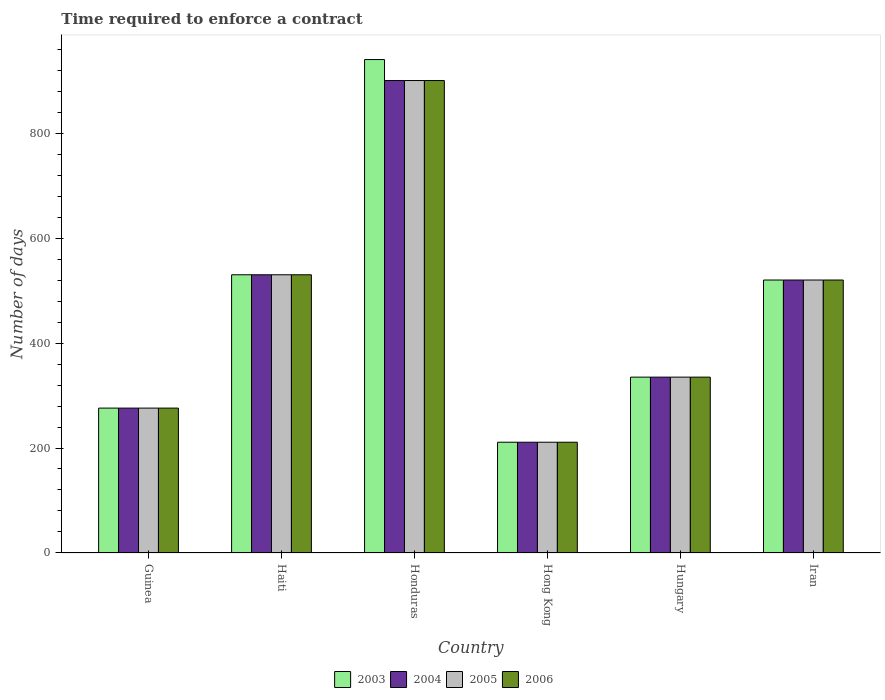How many bars are there on the 4th tick from the left?
Make the answer very short. 4. What is the label of the 1st group of bars from the left?
Keep it short and to the point. Guinea. What is the number of days required to enforce a contract in 2003 in Honduras?
Your response must be concise. 940. Across all countries, what is the maximum number of days required to enforce a contract in 2006?
Offer a terse response. 900. Across all countries, what is the minimum number of days required to enforce a contract in 2006?
Make the answer very short. 211. In which country was the number of days required to enforce a contract in 2003 maximum?
Offer a very short reply. Honduras. In which country was the number of days required to enforce a contract in 2004 minimum?
Your answer should be compact. Hong Kong. What is the total number of days required to enforce a contract in 2003 in the graph?
Ensure brevity in your answer.  2812. What is the difference between the number of days required to enforce a contract in 2004 in Guinea and that in Haiti?
Keep it short and to the point. -254. What is the difference between the number of days required to enforce a contract in 2003 in Hungary and the number of days required to enforce a contract in 2005 in Iran?
Your answer should be very brief. -185. What is the average number of days required to enforce a contract in 2006 per country?
Your answer should be very brief. 462. What is the difference between the number of days required to enforce a contract of/in 2006 and number of days required to enforce a contract of/in 2003 in Guinea?
Your response must be concise. 0. In how many countries, is the number of days required to enforce a contract in 2005 greater than 200 days?
Make the answer very short. 6. What is the ratio of the number of days required to enforce a contract in 2003 in Guinea to that in Iran?
Offer a very short reply. 0.53. Is the number of days required to enforce a contract in 2003 in Haiti less than that in Iran?
Keep it short and to the point. No. What is the difference between the highest and the second highest number of days required to enforce a contract in 2004?
Provide a short and direct response. -10. What is the difference between the highest and the lowest number of days required to enforce a contract in 2006?
Your response must be concise. 689. In how many countries, is the number of days required to enforce a contract in 2004 greater than the average number of days required to enforce a contract in 2004 taken over all countries?
Offer a very short reply. 3. Is the sum of the number of days required to enforce a contract in 2006 in Guinea and Iran greater than the maximum number of days required to enforce a contract in 2005 across all countries?
Provide a short and direct response. No. What does the 2nd bar from the left in Hong Kong represents?
Your answer should be compact. 2004. What does the 1st bar from the right in Hong Kong represents?
Your response must be concise. 2006. Is it the case that in every country, the sum of the number of days required to enforce a contract in 2004 and number of days required to enforce a contract in 2006 is greater than the number of days required to enforce a contract in 2003?
Your answer should be compact. Yes. How many bars are there?
Your answer should be very brief. 24. Are all the bars in the graph horizontal?
Your response must be concise. No. How many countries are there in the graph?
Provide a succinct answer. 6. Are the values on the major ticks of Y-axis written in scientific E-notation?
Make the answer very short. No. Does the graph contain any zero values?
Offer a terse response. No. Does the graph contain grids?
Offer a terse response. No. How many legend labels are there?
Provide a short and direct response. 4. How are the legend labels stacked?
Ensure brevity in your answer.  Horizontal. What is the title of the graph?
Keep it short and to the point. Time required to enforce a contract. Does "1986" appear as one of the legend labels in the graph?
Your answer should be compact. No. What is the label or title of the Y-axis?
Provide a short and direct response. Number of days. What is the Number of days in 2003 in Guinea?
Your answer should be very brief. 276. What is the Number of days of 2004 in Guinea?
Your response must be concise. 276. What is the Number of days in 2005 in Guinea?
Keep it short and to the point. 276. What is the Number of days of 2006 in Guinea?
Your response must be concise. 276. What is the Number of days of 2003 in Haiti?
Make the answer very short. 530. What is the Number of days of 2004 in Haiti?
Your response must be concise. 530. What is the Number of days in 2005 in Haiti?
Provide a short and direct response. 530. What is the Number of days in 2006 in Haiti?
Your response must be concise. 530. What is the Number of days of 2003 in Honduras?
Your answer should be very brief. 940. What is the Number of days in 2004 in Honduras?
Make the answer very short. 900. What is the Number of days in 2005 in Honduras?
Provide a succinct answer. 900. What is the Number of days of 2006 in Honduras?
Give a very brief answer. 900. What is the Number of days in 2003 in Hong Kong?
Your answer should be very brief. 211. What is the Number of days of 2004 in Hong Kong?
Offer a terse response. 211. What is the Number of days in 2005 in Hong Kong?
Make the answer very short. 211. What is the Number of days of 2006 in Hong Kong?
Make the answer very short. 211. What is the Number of days in 2003 in Hungary?
Provide a succinct answer. 335. What is the Number of days of 2004 in Hungary?
Offer a very short reply. 335. What is the Number of days of 2005 in Hungary?
Give a very brief answer. 335. What is the Number of days in 2006 in Hungary?
Give a very brief answer. 335. What is the Number of days in 2003 in Iran?
Your response must be concise. 520. What is the Number of days of 2004 in Iran?
Make the answer very short. 520. What is the Number of days of 2005 in Iran?
Provide a succinct answer. 520. What is the Number of days in 2006 in Iran?
Your response must be concise. 520. Across all countries, what is the maximum Number of days in 2003?
Ensure brevity in your answer.  940. Across all countries, what is the maximum Number of days of 2004?
Provide a short and direct response. 900. Across all countries, what is the maximum Number of days of 2005?
Give a very brief answer. 900. Across all countries, what is the maximum Number of days of 2006?
Offer a very short reply. 900. Across all countries, what is the minimum Number of days of 2003?
Offer a terse response. 211. Across all countries, what is the minimum Number of days in 2004?
Your answer should be very brief. 211. Across all countries, what is the minimum Number of days in 2005?
Make the answer very short. 211. Across all countries, what is the minimum Number of days in 2006?
Keep it short and to the point. 211. What is the total Number of days of 2003 in the graph?
Your answer should be very brief. 2812. What is the total Number of days in 2004 in the graph?
Your response must be concise. 2772. What is the total Number of days in 2005 in the graph?
Offer a very short reply. 2772. What is the total Number of days in 2006 in the graph?
Provide a succinct answer. 2772. What is the difference between the Number of days of 2003 in Guinea and that in Haiti?
Ensure brevity in your answer.  -254. What is the difference between the Number of days of 2004 in Guinea and that in Haiti?
Provide a short and direct response. -254. What is the difference between the Number of days in 2005 in Guinea and that in Haiti?
Your answer should be compact. -254. What is the difference between the Number of days in 2006 in Guinea and that in Haiti?
Your answer should be very brief. -254. What is the difference between the Number of days of 2003 in Guinea and that in Honduras?
Provide a short and direct response. -664. What is the difference between the Number of days of 2004 in Guinea and that in Honduras?
Provide a succinct answer. -624. What is the difference between the Number of days of 2005 in Guinea and that in Honduras?
Your answer should be very brief. -624. What is the difference between the Number of days of 2006 in Guinea and that in Honduras?
Keep it short and to the point. -624. What is the difference between the Number of days in 2005 in Guinea and that in Hong Kong?
Provide a short and direct response. 65. What is the difference between the Number of days of 2006 in Guinea and that in Hong Kong?
Make the answer very short. 65. What is the difference between the Number of days in 2003 in Guinea and that in Hungary?
Give a very brief answer. -59. What is the difference between the Number of days in 2004 in Guinea and that in Hungary?
Keep it short and to the point. -59. What is the difference between the Number of days of 2005 in Guinea and that in Hungary?
Offer a terse response. -59. What is the difference between the Number of days of 2006 in Guinea and that in Hungary?
Offer a very short reply. -59. What is the difference between the Number of days of 2003 in Guinea and that in Iran?
Your answer should be compact. -244. What is the difference between the Number of days of 2004 in Guinea and that in Iran?
Give a very brief answer. -244. What is the difference between the Number of days of 2005 in Guinea and that in Iran?
Ensure brevity in your answer.  -244. What is the difference between the Number of days in 2006 in Guinea and that in Iran?
Offer a terse response. -244. What is the difference between the Number of days of 2003 in Haiti and that in Honduras?
Provide a short and direct response. -410. What is the difference between the Number of days in 2004 in Haiti and that in Honduras?
Give a very brief answer. -370. What is the difference between the Number of days of 2005 in Haiti and that in Honduras?
Give a very brief answer. -370. What is the difference between the Number of days in 2006 in Haiti and that in Honduras?
Your answer should be compact. -370. What is the difference between the Number of days in 2003 in Haiti and that in Hong Kong?
Offer a terse response. 319. What is the difference between the Number of days in 2004 in Haiti and that in Hong Kong?
Keep it short and to the point. 319. What is the difference between the Number of days in 2005 in Haiti and that in Hong Kong?
Give a very brief answer. 319. What is the difference between the Number of days of 2006 in Haiti and that in Hong Kong?
Your response must be concise. 319. What is the difference between the Number of days of 2003 in Haiti and that in Hungary?
Your answer should be very brief. 195. What is the difference between the Number of days of 2004 in Haiti and that in Hungary?
Offer a terse response. 195. What is the difference between the Number of days of 2005 in Haiti and that in Hungary?
Keep it short and to the point. 195. What is the difference between the Number of days of 2006 in Haiti and that in Hungary?
Offer a terse response. 195. What is the difference between the Number of days in 2003 in Haiti and that in Iran?
Offer a terse response. 10. What is the difference between the Number of days of 2003 in Honduras and that in Hong Kong?
Provide a short and direct response. 729. What is the difference between the Number of days of 2004 in Honduras and that in Hong Kong?
Keep it short and to the point. 689. What is the difference between the Number of days in 2005 in Honduras and that in Hong Kong?
Your response must be concise. 689. What is the difference between the Number of days in 2006 in Honduras and that in Hong Kong?
Ensure brevity in your answer.  689. What is the difference between the Number of days of 2003 in Honduras and that in Hungary?
Keep it short and to the point. 605. What is the difference between the Number of days in 2004 in Honduras and that in Hungary?
Ensure brevity in your answer.  565. What is the difference between the Number of days in 2005 in Honduras and that in Hungary?
Your answer should be compact. 565. What is the difference between the Number of days of 2006 in Honduras and that in Hungary?
Your answer should be compact. 565. What is the difference between the Number of days of 2003 in Honduras and that in Iran?
Your answer should be compact. 420. What is the difference between the Number of days in 2004 in Honduras and that in Iran?
Provide a succinct answer. 380. What is the difference between the Number of days in 2005 in Honduras and that in Iran?
Offer a terse response. 380. What is the difference between the Number of days of 2006 in Honduras and that in Iran?
Make the answer very short. 380. What is the difference between the Number of days of 2003 in Hong Kong and that in Hungary?
Your answer should be compact. -124. What is the difference between the Number of days of 2004 in Hong Kong and that in Hungary?
Make the answer very short. -124. What is the difference between the Number of days in 2005 in Hong Kong and that in Hungary?
Offer a terse response. -124. What is the difference between the Number of days in 2006 in Hong Kong and that in Hungary?
Make the answer very short. -124. What is the difference between the Number of days in 2003 in Hong Kong and that in Iran?
Your answer should be very brief. -309. What is the difference between the Number of days of 2004 in Hong Kong and that in Iran?
Make the answer very short. -309. What is the difference between the Number of days of 2005 in Hong Kong and that in Iran?
Provide a short and direct response. -309. What is the difference between the Number of days in 2006 in Hong Kong and that in Iran?
Provide a succinct answer. -309. What is the difference between the Number of days in 2003 in Hungary and that in Iran?
Your answer should be compact. -185. What is the difference between the Number of days of 2004 in Hungary and that in Iran?
Provide a succinct answer. -185. What is the difference between the Number of days of 2005 in Hungary and that in Iran?
Offer a terse response. -185. What is the difference between the Number of days in 2006 in Hungary and that in Iran?
Your response must be concise. -185. What is the difference between the Number of days in 2003 in Guinea and the Number of days in 2004 in Haiti?
Offer a very short reply. -254. What is the difference between the Number of days of 2003 in Guinea and the Number of days of 2005 in Haiti?
Make the answer very short. -254. What is the difference between the Number of days in 2003 in Guinea and the Number of days in 2006 in Haiti?
Keep it short and to the point. -254. What is the difference between the Number of days in 2004 in Guinea and the Number of days in 2005 in Haiti?
Your answer should be very brief. -254. What is the difference between the Number of days of 2004 in Guinea and the Number of days of 2006 in Haiti?
Provide a short and direct response. -254. What is the difference between the Number of days of 2005 in Guinea and the Number of days of 2006 in Haiti?
Keep it short and to the point. -254. What is the difference between the Number of days of 2003 in Guinea and the Number of days of 2004 in Honduras?
Offer a terse response. -624. What is the difference between the Number of days of 2003 in Guinea and the Number of days of 2005 in Honduras?
Give a very brief answer. -624. What is the difference between the Number of days in 2003 in Guinea and the Number of days in 2006 in Honduras?
Keep it short and to the point. -624. What is the difference between the Number of days of 2004 in Guinea and the Number of days of 2005 in Honduras?
Keep it short and to the point. -624. What is the difference between the Number of days in 2004 in Guinea and the Number of days in 2006 in Honduras?
Your answer should be compact. -624. What is the difference between the Number of days of 2005 in Guinea and the Number of days of 2006 in Honduras?
Your answer should be very brief. -624. What is the difference between the Number of days in 2003 in Guinea and the Number of days in 2005 in Hong Kong?
Offer a terse response. 65. What is the difference between the Number of days in 2003 in Guinea and the Number of days in 2006 in Hong Kong?
Your answer should be very brief. 65. What is the difference between the Number of days of 2004 in Guinea and the Number of days of 2005 in Hong Kong?
Your answer should be compact. 65. What is the difference between the Number of days in 2003 in Guinea and the Number of days in 2004 in Hungary?
Make the answer very short. -59. What is the difference between the Number of days in 2003 in Guinea and the Number of days in 2005 in Hungary?
Offer a very short reply. -59. What is the difference between the Number of days in 2003 in Guinea and the Number of days in 2006 in Hungary?
Your response must be concise. -59. What is the difference between the Number of days of 2004 in Guinea and the Number of days of 2005 in Hungary?
Your response must be concise. -59. What is the difference between the Number of days of 2004 in Guinea and the Number of days of 2006 in Hungary?
Your answer should be compact. -59. What is the difference between the Number of days in 2005 in Guinea and the Number of days in 2006 in Hungary?
Your answer should be compact. -59. What is the difference between the Number of days in 2003 in Guinea and the Number of days in 2004 in Iran?
Make the answer very short. -244. What is the difference between the Number of days of 2003 in Guinea and the Number of days of 2005 in Iran?
Make the answer very short. -244. What is the difference between the Number of days in 2003 in Guinea and the Number of days in 2006 in Iran?
Ensure brevity in your answer.  -244. What is the difference between the Number of days of 2004 in Guinea and the Number of days of 2005 in Iran?
Keep it short and to the point. -244. What is the difference between the Number of days of 2004 in Guinea and the Number of days of 2006 in Iran?
Ensure brevity in your answer.  -244. What is the difference between the Number of days of 2005 in Guinea and the Number of days of 2006 in Iran?
Your answer should be compact. -244. What is the difference between the Number of days in 2003 in Haiti and the Number of days in 2004 in Honduras?
Offer a very short reply. -370. What is the difference between the Number of days in 2003 in Haiti and the Number of days in 2005 in Honduras?
Provide a succinct answer. -370. What is the difference between the Number of days in 2003 in Haiti and the Number of days in 2006 in Honduras?
Offer a very short reply. -370. What is the difference between the Number of days of 2004 in Haiti and the Number of days of 2005 in Honduras?
Provide a short and direct response. -370. What is the difference between the Number of days of 2004 in Haiti and the Number of days of 2006 in Honduras?
Make the answer very short. -370. What is the difference between the Number of days in 2005 in Haiti and the Number of days in 2006 in Honduras?
Make the answer very short. -370. What is the difference between the Number of days in 2003 in Haiti and the Number of days in 2004 in Hong Kong?
Your response must be concise. 319. What is the difference between the Number of days of 2003 in Haiti and the Number of days of 2005 in Hong Kong?
Offer a terse response. 319. What is the difference between the Number of days in 2003 in Haiti and the Number of days in 2006 in Hong Kong?
Give a very brief answer. 319. What is the difference between the Number of days of 2004 in Haiti and the Number of days of 2005 in Hong Kong?
Provide a short and direct response. 319. What is the difference between the Number of days of 2004 in Haiti and the Number of days of 2006 in Hong Kong?
Provide a short and direct response. 319. What is the difference between the Number of days in 2005 in Haiti and the Number of days in 2006 in Hong Kong?
Provide a short and direct response. 319. What is the difference between the Number of days in 2003 in Haiti and the Number of days in 2004 in Hungary?
Your answer should be very brief. 195. What is the difference between the Number of days in 2003 in Haiti and the Number of days in 2005 in Hungary?
Provide a succinct answer. 195. What is the difference between the Number of days of 2003 in Haiti and the Number of days of 2006 in Hungary?
Offer a terse response. 195. What is the difference between the Number of days of 2004 in Haiti and the Number of days of 2005 in Hungary?
Give a very brief answer. 195. What is the difference between the Number of days of 2004 in Haiti and the Number of days of 2006 in Hungary?
Make the answer very short. 195. What is the difference between the Number of days in 2005 in Haiti and the Number of days in 2006 in Hungary?
Ensure brevity in your answer.  195. What is the difference between the Number of days in 2003 in Haiti and the Number of days in 2004 in Iran?
Keep it short and to the point. 10. What is the difference between the Number of days of 2003 in Haiti and the Number of days of 2005 in Iran?
Provide a succinct answer. 10. What is the difference between the Number of days of 2003 in Haiti and the Number of days of 2006 in Iran?
Offer a very short reply. 10. What is the difference between the Number of days in 2004 in Haiti and the Number of days in 2005 in Iran?
Provide a short and direct response. 10. What is the difference between the Number of days of 2004 in Haiti and the Number of days of 2006 in Iran?
Offer a terse response. 10. What is the difference between the Number of days in 2003 in Honduras and the Number of days in 2004 in Hong Kong?
Give a very brief answer. 729. What is the difference between the Number of days in 2003 in Honduras and the Number of days in 2005 in Hong Kong?
Keep it short and to the point. 729. What is the difference between the Number of days in 2003 in Honduras and the Number of days in 2006 in Hong Kong?
Your answer should be very brief. 729. What is the difference between the Number of days of 2004 in Honduras and the Number of days of 2005 in Hong Kong?
Provide a short and direct response. 689. What is the difference between the Number of days in 2004 in Honduras and the Number of days in 2006 in Hong Kong?
Keep it short and to the point. 689. What is the difference between the Number of days of 2005 in Honduras and the Number of days of 2006 in Hong Kong?
Provide a succinct answer. 689. What is the difference between the Number of days in 2003 in Honduras and the Number of days in 2004 in Hungary?
Offer a terse response. 605. What is the difference between the Number of days of 2003 in Honduras and the Number of days of 2005 in Hungary?
Keep it short and to the point. 605. What is the difference between the Number of days of 2003 in Honduras and the Number of days of 2006 in Hungary?
Offer a terse response. 605. What is the difference between the Number of days in 2004 in Honduras and the Number of days in 2005 in Hungary?
Your response must be concise. 565. What is the difference between the Number of days in 2004 in Honduras and the Number of days in 2006 in Hungary?
Your answer should be very brief. 565. What is the difference between the Number of days in 2005 in Honduras and the Number of days in 2006 in Hungary?
Offer a very short reply. 565. What is the difference between the Number of days in 2003 in Honduras and the Number of days in 2004 in Iran?
Offer a terse response. 420. What is the difference between the Number of days of 2003 in Honduras and the Number of days of 2005 in Iran?
Your answer should be compact. 420. What is the difference between the Number of days of 2003 in Honduras and the Number of days of 2006 in Iran?
Give a very brief answer. 420. What is the difference between the Number of days in 2004 in Honduras and the Number of days in 2005 in Iran?
Your response must be concise. 380. What is the difference between the Number of days in 2004 in Honduras and the Number of days in 2006 in Iran?
Your answer should be very brief. 380. What is the difference between the Number of days of 2005 in Honduras and the Number of days of 2006 in Iran?
Provide a short and direct response. 380. What is the difference between the Number of days of 2003 in Hong Kong and the Number of days of 2004 in Hungary?
Your response must be concise. -124. What is the difference between the Number of days of 2003 in Hong Kong and the Number of days of 2005 in Hungary?
Your response must be concise. -124. What is the difference between the Number of days of 2003 in Hong Kong and the Number of days of 2006 in Hungary?
Your response must be concise. -124. What is the difference between the Number of days in 2004 in Hong Kong and the Number of days in 2005 in Hungary?
Your response must be concise. -124. What is the difference between the Number of days of 2004 in Hong Kong and the Number of days of 2006 in Hungary?
Make the answer very short. -124. What is the difference between the Number of days of 2005 in Hong Kong and the Number of days of 2006 in Hungary?
Your answer should be very brief. -124. What is the difference between the Number of days of 2003 in Hong Kong and the Number of days of 2004 in Iran?
Give a very brief answer. -309. What is the difference between the Number of days of 2003 in Hong Kong and the Number of days of 2005 in Iran?
Your response must be concise. -309. What is the difference between the Number of days in 2003 in Hong Kong and the Number of days in 2006 in Iran?
Your answer should be very brief. -309. What is the difference between the Number of days in 2004 in Hong Kong and the Number of days in 2005 in Iran?
Your response must be concise. -309. What is the difference between the Number of days in 2004 in Hong Kong and the Number of days in 2006 in Iran?
Provide a short and direct response. -309. What is the difference between the Number of days of 2005 in Hong Kong and the Number of days of 2006 in Iran?
Offer a terse response. -309. What is the difference between the Number of days of 2003 in Hungary and the Number of days of 2004 in Iran?
Provide a succinct answer. -185. What is the difference between the Number of days of 2003 in Hungary and the Number of days of 2005 in Iran?
Make the answer very short. -185. What is the difference between the Number of days in 2003 in Hungary and the Number of days in 2006 in Iran?
Offer a terse response. -185. What is the difference between the Number of days of 2004 in Hungary and the Number of days of 2005 in Iran?
Provide a succinct answer. -185. What is the difference between the Number of days of 2004 in Hungary and the Number of days of 2006 in Iran?
Provide a succinct answer. -185. What is the difference between the Number of days in 2005 in Hungary and the Number of days in 2006 in Iran?
Your answer should be very brief. -185. What is the average Number of days of 2003 per country?
Provide a short and direct response. 468.67. What is the average Number of days of 2004 per country?
Make the answer very short. 462. What is the average Number of days in 2005 per country?
Offer a very short reply. 462. What is the average Number of days in 2006 per country?
Your response must be concise. 462. What is the difference between the Number of days of 2003 and Number of days of 2004 in Guinea?
Give a very brief answer. 0. What is the difference between the Number of days of 2003 and Number of days of 2005 in Guinea?
Your response must be concise. 0. What is the difference between the Number of days in 2003 and Number of days in 2006 in Guinea?
Offer a very short reply. 0. What is the difference between the Number of days in 2004 and Number of days in 2005 in Guinea?
Offer a very short reply. 0. What is the difference between the Number of days of 2003 and Number of days of 2004 in Haiti?
Offer a very short reply. 0. What is the difference between the Number of days in 2003 and Number of days in 2005 in Haiti?
Provide a short and direct response. 0. What is the difference between the Number of days in 2004 and Number of days in 2005 in Haiti?
Provide a short and direct response. 0. What is the difference between the Number of days in 2005 and Number of days in 2006 in Haiti?
Your answer should be very brief. 0. What is the difference between the Number of days of 2003 and Number of days of 2004 in Honduras?
Keep it short and to the point. 40. What is the difference between the Number of days of 2003 and Number of days of 2005 in Honduras?
Give a very brief answer. 40. What is the difference between the Number of days in 2004 and Number of days in 2005 in Honduras?
Your answer should be very brief. 0. What is the difference between the Number of days in 2005 and Number of days in 2006 in Honduras?
Give a very brief answer. 0. What is the difference between the Number of days in 2003 and Number of days in 2006 in Hong Kong?
Provide a succinct answer. 0. What is the difference between the Number of days of 2004 and Number of days of 2005 in Hong Kong?
Your response must be concise. 0. What is the difference between the Number of days of 2004 and Number of days of 2006 in Hong Kong?
Make the answer very short. 0. What is the difference between the Number of days of 2003 and Number of days of 2005 in Hungary?
Ensure brevity in your answer.  0. What is the difference between the Number of days of 2003 and Number of days of 2004 in Iran?
Ensure brevity in your answer.  0. What is the ratio of the Number of days of 2003 in Guinea to that in Haiti?
Offer a terse response. 0.52. What is the ratio of the Number of days in 2004 in Guinea to that in Haiti?
Your answer should be very brief. 0.52. What is the ratio of the Number of days of 2005 in Guinea to that in Haiti?
Provide a succinct answer. 0.52. What is the ratio of the Number of days in 2006 in Guinea to that in Haiti?
Offer a terse response. 0.52. What is the ratio of the Number of days in 2003 in Guinea to that in Honduras?
Your response must be concise. 0.29. What is the ratio of the Number of days in 2004 in Guinea to that in Honduras?
Give a very brief answer. 0.31. What is the ratio of the Number of days of 2005 in Guinea to that in Honduras?
Ensure brevity in your answer.  0.31. What is the ratio of the Number of days in 2006 in Guinea to that in Honduras?
Ensure brevity in your answer.  0.31. What is the ratio of the Number of days in 2003 in Guinea to that in Hong Kong?
Offer a very short reply. 1.31. What is the ratio of the Number of days of 2004 in Guinea to that in Hong Kong?
Your answer should be compact. 1.31. What is the ratio of the Number of days in 2005 in Guinea to that in Hong Kong?
Your answer should be compact. 1.31. What is the ratio of the Number of days in 2006 in Guinea to that in Hong Kong?
Your answer should be compact. 1.31. What is the ratio of the Number of days of 2003 in Guinea to that in Hungary?
Offer a very short reply. 0.82. What is the ratio of the Number of days of 2004 in Guinea to that in Hungary?
Your response must be concise. 0.82. What is the ratio of the Number of days of 2005 in Guinea to that in Hungary?
Offer a terse response. 0.82. What is the ratio of the Number of days in 2006 in Guinea to that in Hungary?
Your answer should be compact. 0.82. What is the ratio of the Number of days of 2003 in Guinea to that in Iran?
Your answer should be compact. 0.53. What is the ratio of the Number of days of 2004 in Guinea to that in Iran?
Provide a succinct answer. 0.53. What is the ratio of the Number of days of 2005 in Guinea to that in Iran?
Keep it short and to the point. 0.53. What is the ratio of the Number of days of 2006 in Guinea to that in Iran?
Your response must be concise. 0.53. What is the ratio of the Number of days of 2003 in Haiti to that in Honduras?
Keep it short and to the point. 0.56. What is the ratio of the Number of days of 2004 in Haiti to that in Honduras?
Provide a short and direct response. 0.59. What is the ratio of the Number of days of 2005 in Haiti to that in Honduras?
Provide a succinct answer. 0.59. What is the ratio of the Number of days in 2006 in Haiti to that in Honduras?
Provide a short and direct response. 0.59. What is the ratio of the Number of days in 2003 in Haiti to that in Hong Kong?
Make the answer very short. 2.51. What is the ratio of the Number of days of 2004 in Haiti to that in Hong Kong?
Offer a terse response. 2.51. What is the ratio of the Number of days of 2005 in Haiti to that in Hong Kong?
Your response must be concise. 2.51. What is the ratio of the Number of days of 2006 in Haiti to that in Hong Kong?
Keep it short and to the point. 2.51. What is the ratio of the Number of days in 2003 in Haiti to that in Hungary?
Provide a succinct answer. 1.58. What is the ratio of the Number of days of 2004 in Haiti to that in Hungary?
Your answer should be compact. 1.58. What is the ratio of the Number of days in 2005 in Haiti to that in Hungary?
Offer a terse response. 1.58. What is the ratio of the Number of days of 2006 in Haiti to that in Hungary?
Give a very brief answer. 1.58. What is the ratio of the Number of days in 2003 in Haiti to that in Iran?
Make the answer very short. 1.02. What is the ratio of the Number of days in 2004 in Haiti to that in Iran?
Provide a short and direct response. 1.02. What is the ratio of the Number of days of 2005 in Haiti to that in Iran?
Make the answer very short. 1.02. What is the ratio of the Number of days in 2006 in Haiti to that in Iran?
Make the answer very short. 1.02. What is the ratio of the Number of days of 2003 in Honduras to that in Hong Kong?
Your answer should be very brief. 4.46. What is the ratio of the Number of days in 2004 in Honduras to that in Hong Kong?
Provide a succinct answer. 4.27. What is the ratio of the Number of days of 2005 in Honduras to that in Hong Kong?
Offer a very short reply. 4.27. What is the ratio of the Number of days in 2006 in Honduras to that in Hong Kong?
Offer a very short reply. 4.27. What is the ratio of the Number of days in 2003 in Honduras to that in Hungary?
Your response must be concise. 2.81. What is the ratio of the Number of days in 2004 in Honduras to that in Hungary?
Keep it short and to the point. 2.69. What is the ratio of the Number of days in 2005 in Honduras to that in Hungary?
Provide a succinct answer. 2.69. What is the ratio of the Number of days of 2006 in Honduras to that in Hungary?
Make the answer very short. 2.69. What is the ratio of the Number of days in 2003 in Honduras to that in Iran?
Offer a very short reply. 1.81. What is the ratio of the Number of days in 2004 in Honduras to that in Iran?
Give a very brief answer. 1.73. What is the ratio of the Number of days in 2005 in Honduras to that in Iran?
Give a very brief answer. 1.73. What is the ratio of the Number of days in 2006 in Honduras to that in Iran?
Offer a very short reply. 1.73. What is the ratio of the Number of days of 2003 in Hong Kong to that in Hungary?
Your answer should be very brief. 0.63. What is the ratio of the Number of days of 2004 in Hong Kong to that in Hungary?
Ensure brevity in your answer.  0.63. What is the ratio of the Number of days of 2005 in Hong Kong to that in Hungary?
Provide a short and direct response. 0.63. What is the ratio of the Number of days of 2006 in Hong Kong to that in Hungary?
Give a very brief answer. 0.63. What is the ratio of the Number of days in 2003 in Hong Kong to that in Iran?
Ensure brevity in your answer.  0.41. What is the ratio of the Number of days of 2004 in Hong Kong to that in Iran?
Your answer should be compact. 0.41. What is the ratio of the Number of days of 2005 in Hong Kong to that in Iran?
Keep it short and to the point. 0.41. What is the ratio of the Number of days in 2006 in Hong Kong to that in Iran?
Your response must be concise. 0.41. What is the ratio of the Number of days in 2003 in Hungary to that in Iran?
Offer a terse response. 0.64. What is the ratio of the Number of days of 2004 in Hungary to that in Iran?
Give a very brief answer. 0.64. What is the ratio of the Number of days in 2005 in Hungary to that in Iran?
Your answer should be very brief. 0.64. What is the ratio of the Number of days in 2006 in Hungary to that in Iran?
Keep it short and to the point. 0.64. What is the difference between the highest and the second highest Number of days in 2003?
Ensure brevity in your answer.  410. What is the difference between the highest and the second highest Number of days in 2004?
Keep it short and to the point. 370. What is the difference between the highest and the second highest Number of days in 2005?
Make the answer very short. 370. What is the difference between the highest and the second highest Number of days of 2006?
Keep it short and to the point. 370. What is the difference between the highest and the lowest Number of days of 2003?
Your response must be concise. 729. What is the difference between the highest and the lowest Number of days in 2004?
Provide a short and direct response. 689. What is the difference between the highest and the lowest Number of days in 2005?
Provide a succinct answer. 689. What is the difference between the highest and the lowest Number of days of 2006?
Your answer should be very brief. 689. 